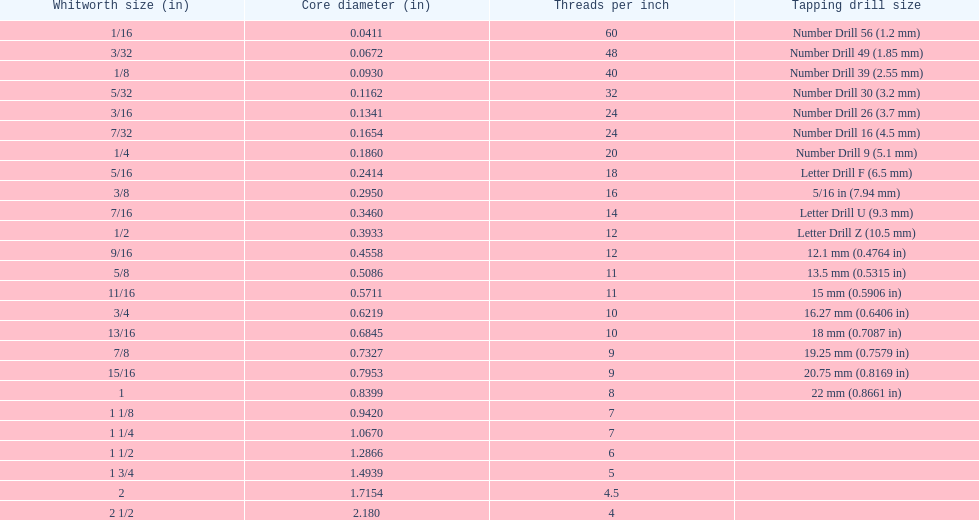Which whitworth size has the same number of threads per inch as 3/16? 7/32. 